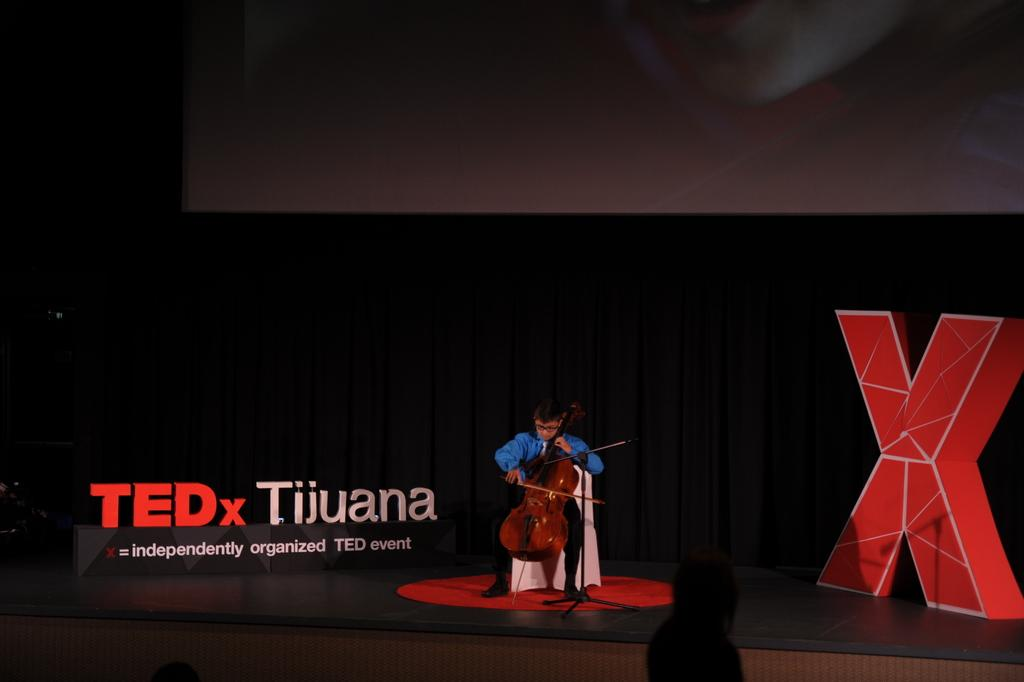What is the main subject of the image? There is a child in the image. What is the child doing in the image? The child is sitting on a chair and playing a violin. Where is the child located in the image? The child is on a stage. What can be seen in the background of the image? There is a black curtain in the background of the image. What type of sand can be seen on the floor in the image? There is no sand visible in the image; it features a child playing a violin on a stage with a black curtain in the background. 